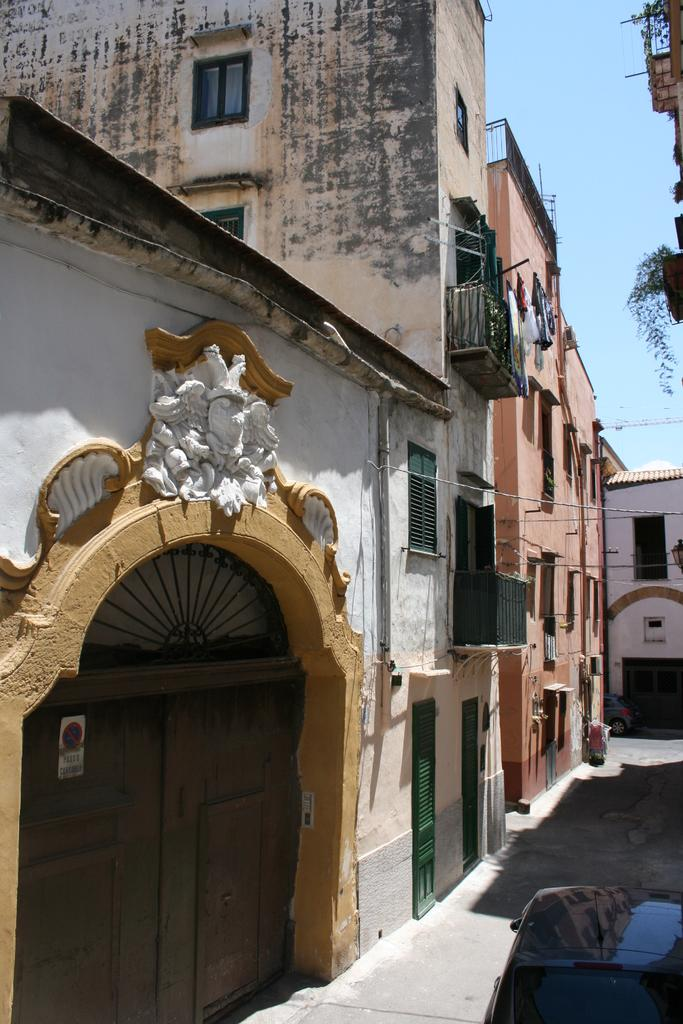What type of structures can be seen in the image? There are buildings in the image. What else is visible in the image besides the buildings? Cables and vehicles are present in the image. Where is the poster located in the image? The poster is on a door on the left side of the image. How many sheep are visible in the image? There are no sheep present in the image. What type of soap is being used to clean the vehicles in the image? There is no soap or cleaning activity depicted in the image. 